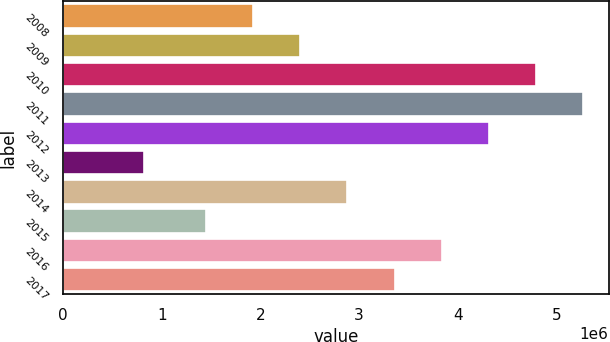Convert chart. <chart><loc_0><loc_0><loc_500><loc_500><bar_chart><fcel>2008<fcel>2009<fcel>2010<fcel>2011<fcel>2012<fcel>2013<fcel>2014<fcel>2015<fcel>2016<fcel>2017<nl><fcel>1.92882e+06<fcel>2.40567e+06<fcel>4.78988e+06<fcel>5.26673e+06<fcel>4.31304e+06<fcel>822886<fcel>2.88251e+06<fcel>1.45198e+06<fcel>3.8362e+06<fcel>3.35935e+06<nl></chart> 